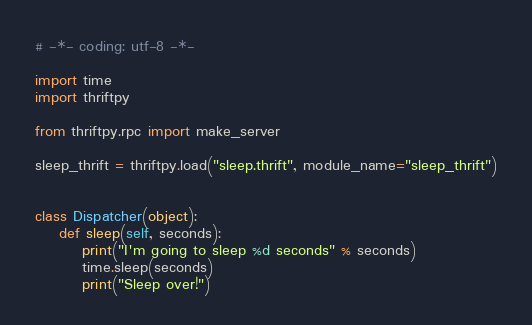<code> <loc_0><loc_0><loc_500><loc_500><_Python_># -*- coding: utf-8 -*-

import time
import thriftpy

from thriftpy.rpc import make_server

sleep_thrift = thriftpy.load("sleep.thrift", module_name="sleep_thrift")


class Dispatcher(object):
    def sleep(self, seconds):
        print("I'm going to sleep %d seconds" % seconds)
        time.sleep(seconds)
        print("Sleep over!")

</code> 